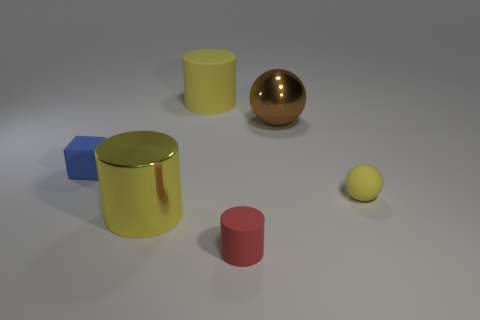Can you tell me what materials the objects appear to be made of? Certainly! The objects seem to display different materials. The smaller yellow and red cylinders look matte, possibly simulating plastic, while the blue cube has a matte surface too, suggesting a similar material. The larger golden sphere has a reflective surface, hinting that it may represent a metallic material. 